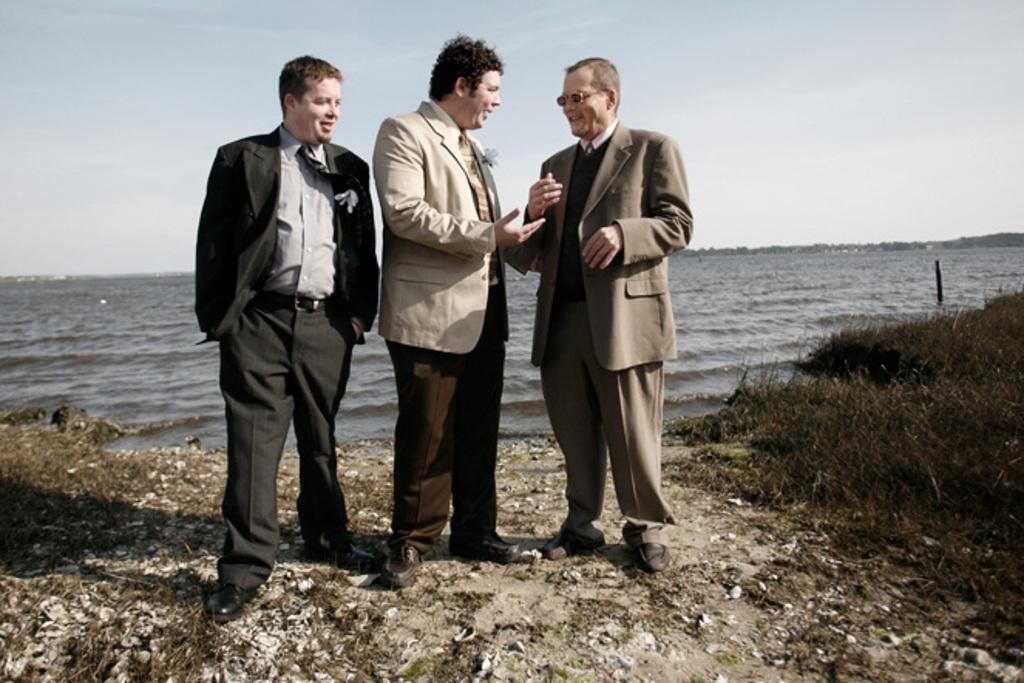Can you describe this image briefly? This picture shows few men standing with a smile on their faces and they wore coats and ties and we see grass on the ground and water on their back and we see a cloudy sky. 